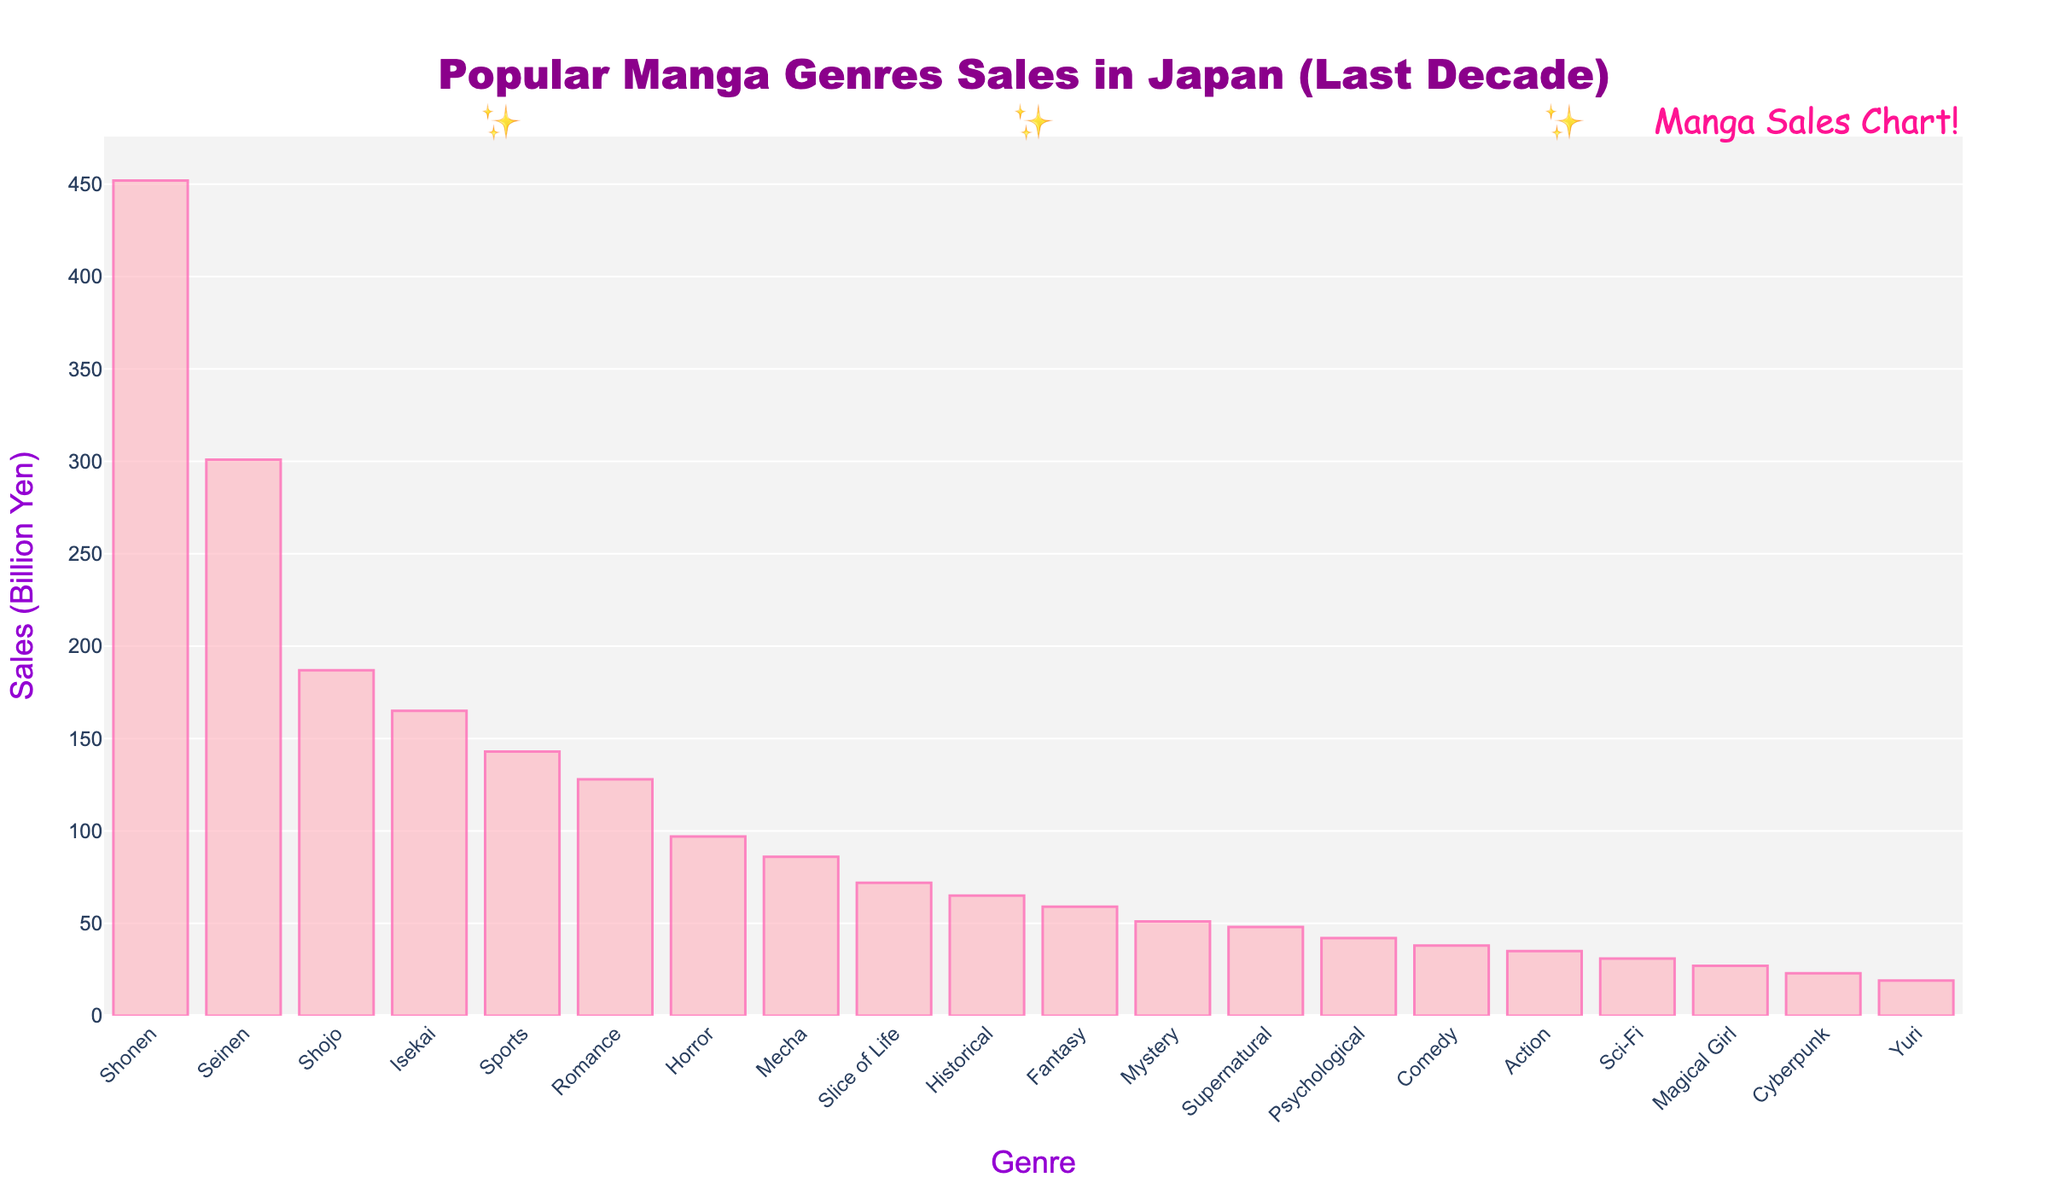What's the top-selling manga genre over the last decade? The tallest bar on the bar chart represents the top-selling manga genre. By observing the chart, the tallest bar represents the 'Shonen' genre.
Answer: Shonen Which genre has higher sales, Seinen or Shojo? Compare the heights of the bars representing 'Seinen' and 'Shojo'. The 'Seinen' bar is taller than the 'Shojo' bar, indicating higher sales.
Answer: Seinen What are the total sales of Shonen and Seinen genres combined? Look at the sales figures for 'Shonen' (452 Billion Yen) and 'Seinen' (301 Billion Yen). Add these two figures together: 452 + 301 = 753.
Answer: 753 Billion Yen How does the sales figure for Sports compare to Romance? Compare the heights of the bars for 'Sports' and 'Romance'. The 'Sports' bar is taller than the 'Romance' bar, indicating higher sales.
Answer: Sports Which genre sales are closest to 100 Billion Yen? Look at the bars around the 100 Billion Yen mark on the vertical axis. 'Horror' has a sales figure of 97 Billion Yen, which is closest to 100 Billion Yen.
Answer: Horror How much more sales does Shonen have compared to Psychological manga? Find the sales figures of 'Shonen' (452 Billion Yen) and 'Psychological' (42 Billion Yen). Subtract the smaller figure from the larger: 452 - 42 = 410.
Answer: 410 Billion Yen What is the combined sales figure for the genres with less than 50 Billion Yen in sales? Identify the genres with less than 50 Billion Yen in sales: Cyberpunk (23), Yuri (19), Magical Girl (27), Sci-Fi (31), Action (35), Comedy (38), and Supernatural (48). Sum these values: 23 + 19 + 27 + 31 + 35 + 38 + 48 = 221.
Answer: 221 Billion Yen What is the average sales figure for the three least selling genres? Identify the three least selling genres: Cyberpunk (23), Yuri (19), and Magical Girl (27). Calculate the average: (23 + 19 + 27) / 3 = 23.
Answer: 23 Billion Yen Which genre has the most visually striking bar, considering color contrast and position? The bar colors are light pink with a hot pink border. The genre at the far left, 'Shonen', is most visually striking due to being the tallest and most prominent in the sequence.
Answer: Shonen 